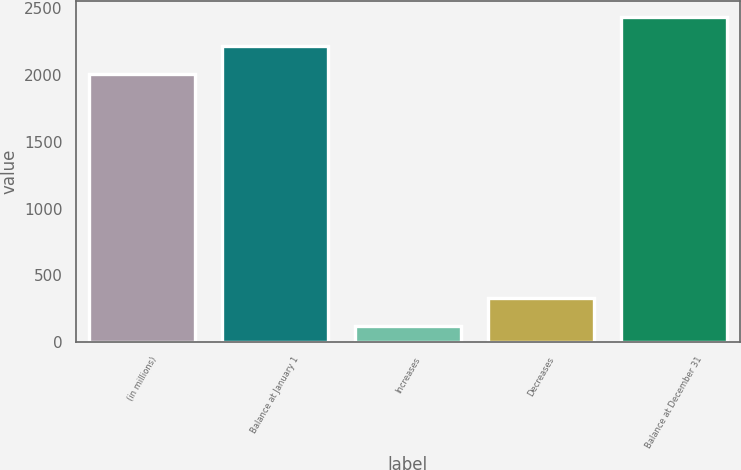Convert chart. <chart><loc_0><loc_0><loc_500><loc_500><bar_chart><fcel>(in millions)<fcel>Balance at January 1<fcel>Increases<fcel>Decreases<fcel>Balance at December 31<nl><fcel>2008<fcel>2219.9<fcel>118<fcel>329.9<fcel>2431.8<nl></chart> 